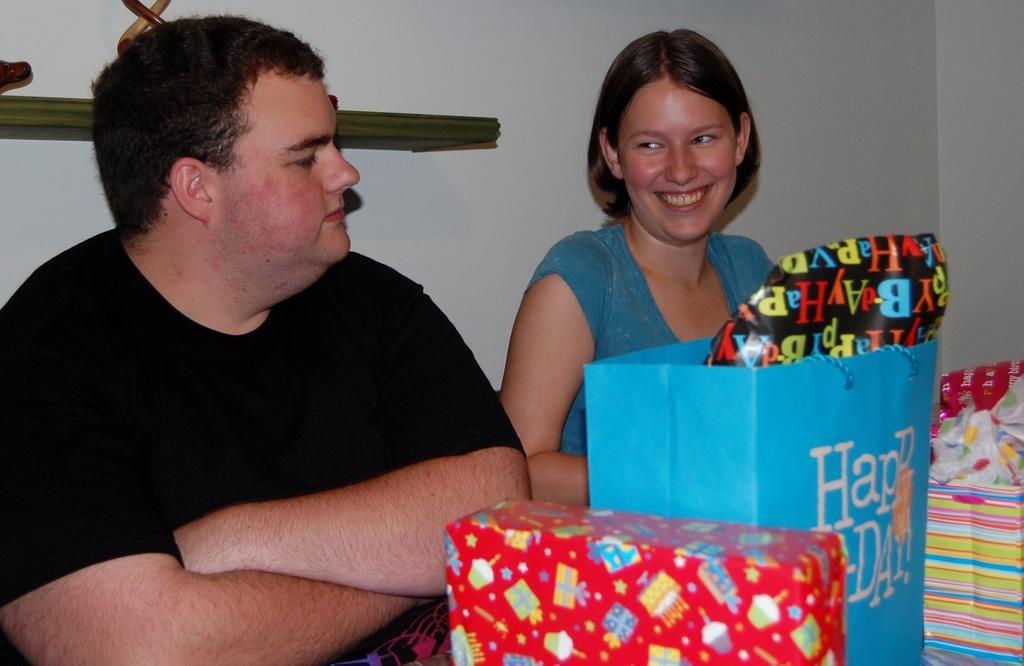Who are the people in the image? There is a man and a woman in the image. What might be the occasion or event based on the presence of gifts? The presence of gifts suggests that there might be a special occasion or event. What can be seen in the background of the image? There is a wall in the background of the image. What type of cord is being used to communicate with the man in the image? There is no cord visible in the image, and the man's ability to communicate cannot be determined from the image alone. What is the purpose of the gifts in the image? The purpose of the gifts cannot be determined from the image alone, as it depends on the context and occasion. 